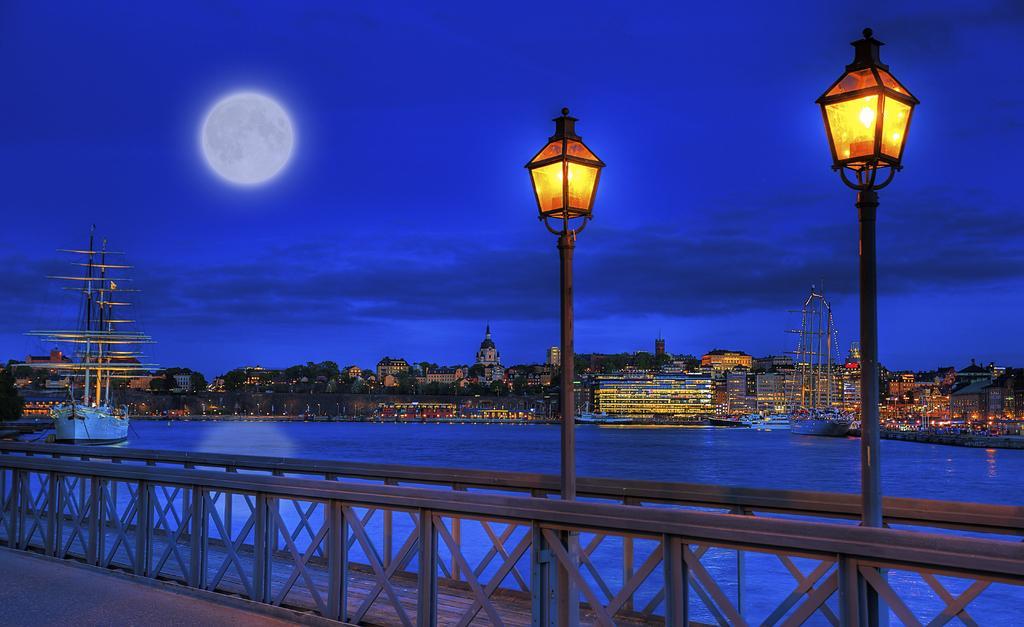Please provide a concise description of this image. Here we can see railing and light poles. Background we can see boats, water, buildings and trees. Moon in the sky.  